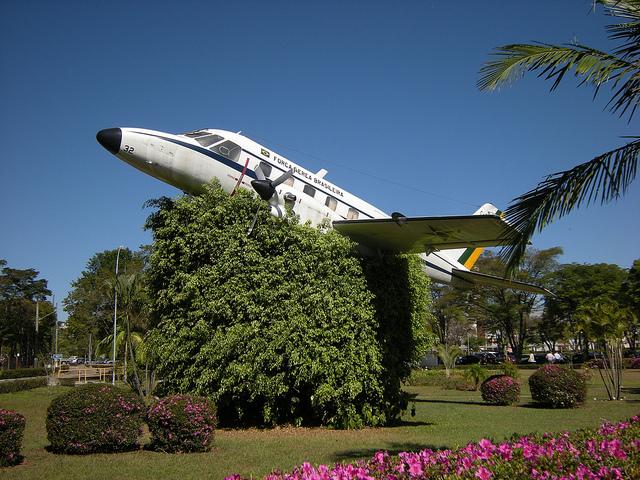Is the airplane flying in the air?
Answer briefly. No. Has this air plane crashed?
Concise answer only. No. Is this a sunny day?
Give a very brief answer. Yes. 